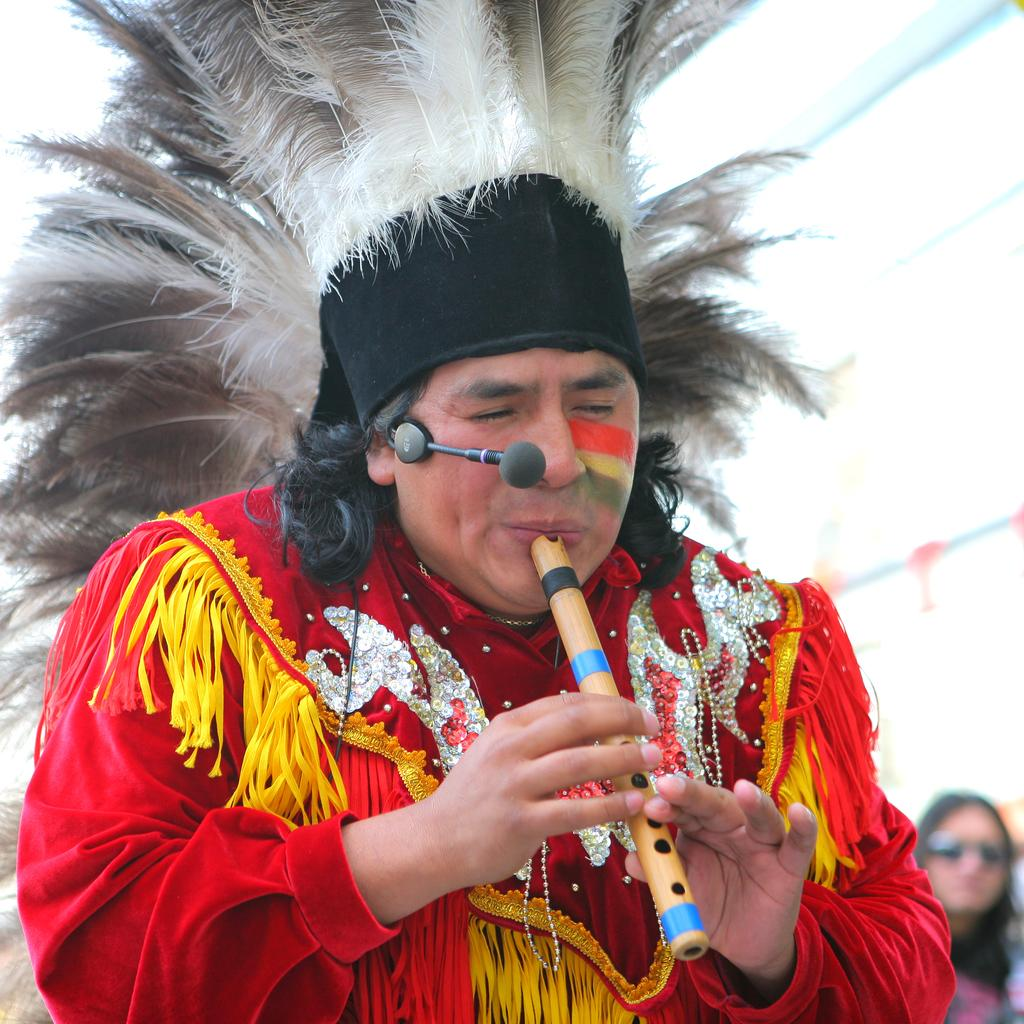What is the main subject of the image? The main subject of the image is a person. What is the person wearing on their head? The person is wearing something on their head. What object is present in the image that is typically used for amplifying sound? There is a microphone present in the image. What musical instrument is the person playing in the image? The person is playing a flute. How many secretaries are present in the image? There are no secretaries present in the image. What type of family gathering is depicted in the image? There is no family gathering depicted in the image. How many balls can be seen in the image? There are no balls present in the image. 